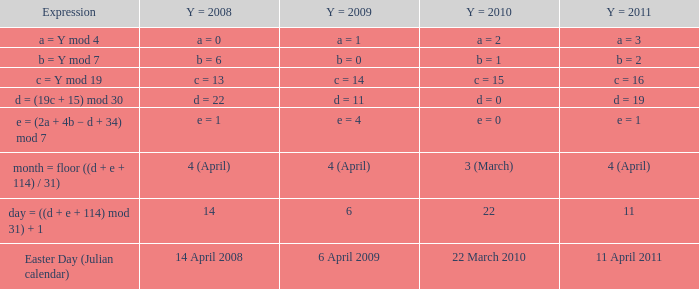What is the y = 2011 when the expression is month = floor ((d + e + 114) / 31)? 4 (April). 